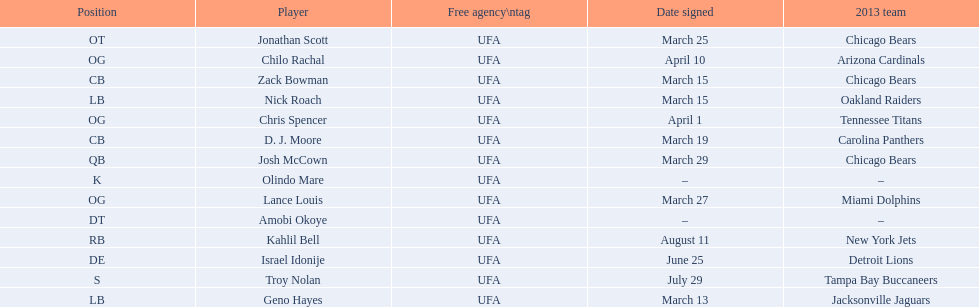What are all the dates signed? March 29, August 11, March 27, April 1, April 10, March 25, June 25, March 13, March 15, March 15, March 19, July 29. Which of these are duplicates? March 15, March 15. Who has the same one as nick roach? Zack Bowman. 